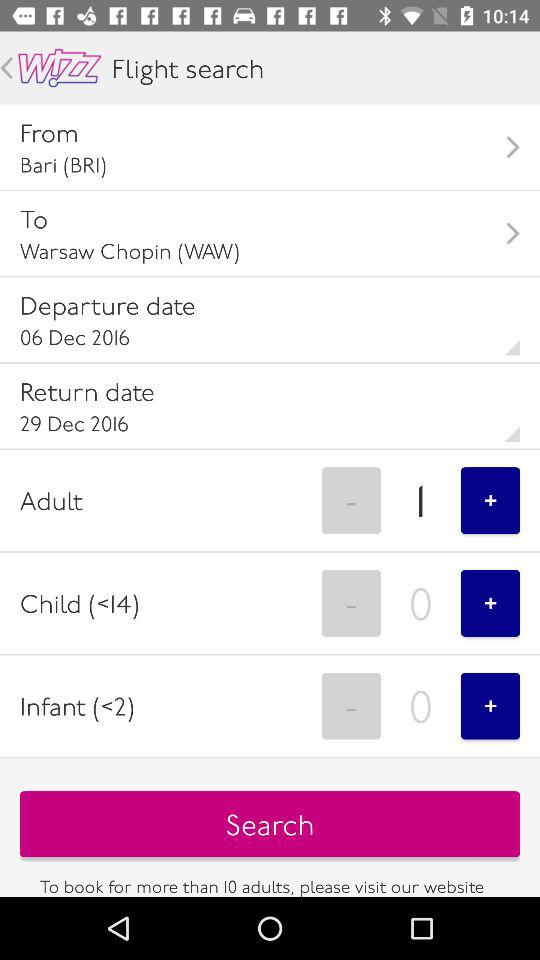What is the departure date of the flight? The departure date of the flight is December 6, 2016. 